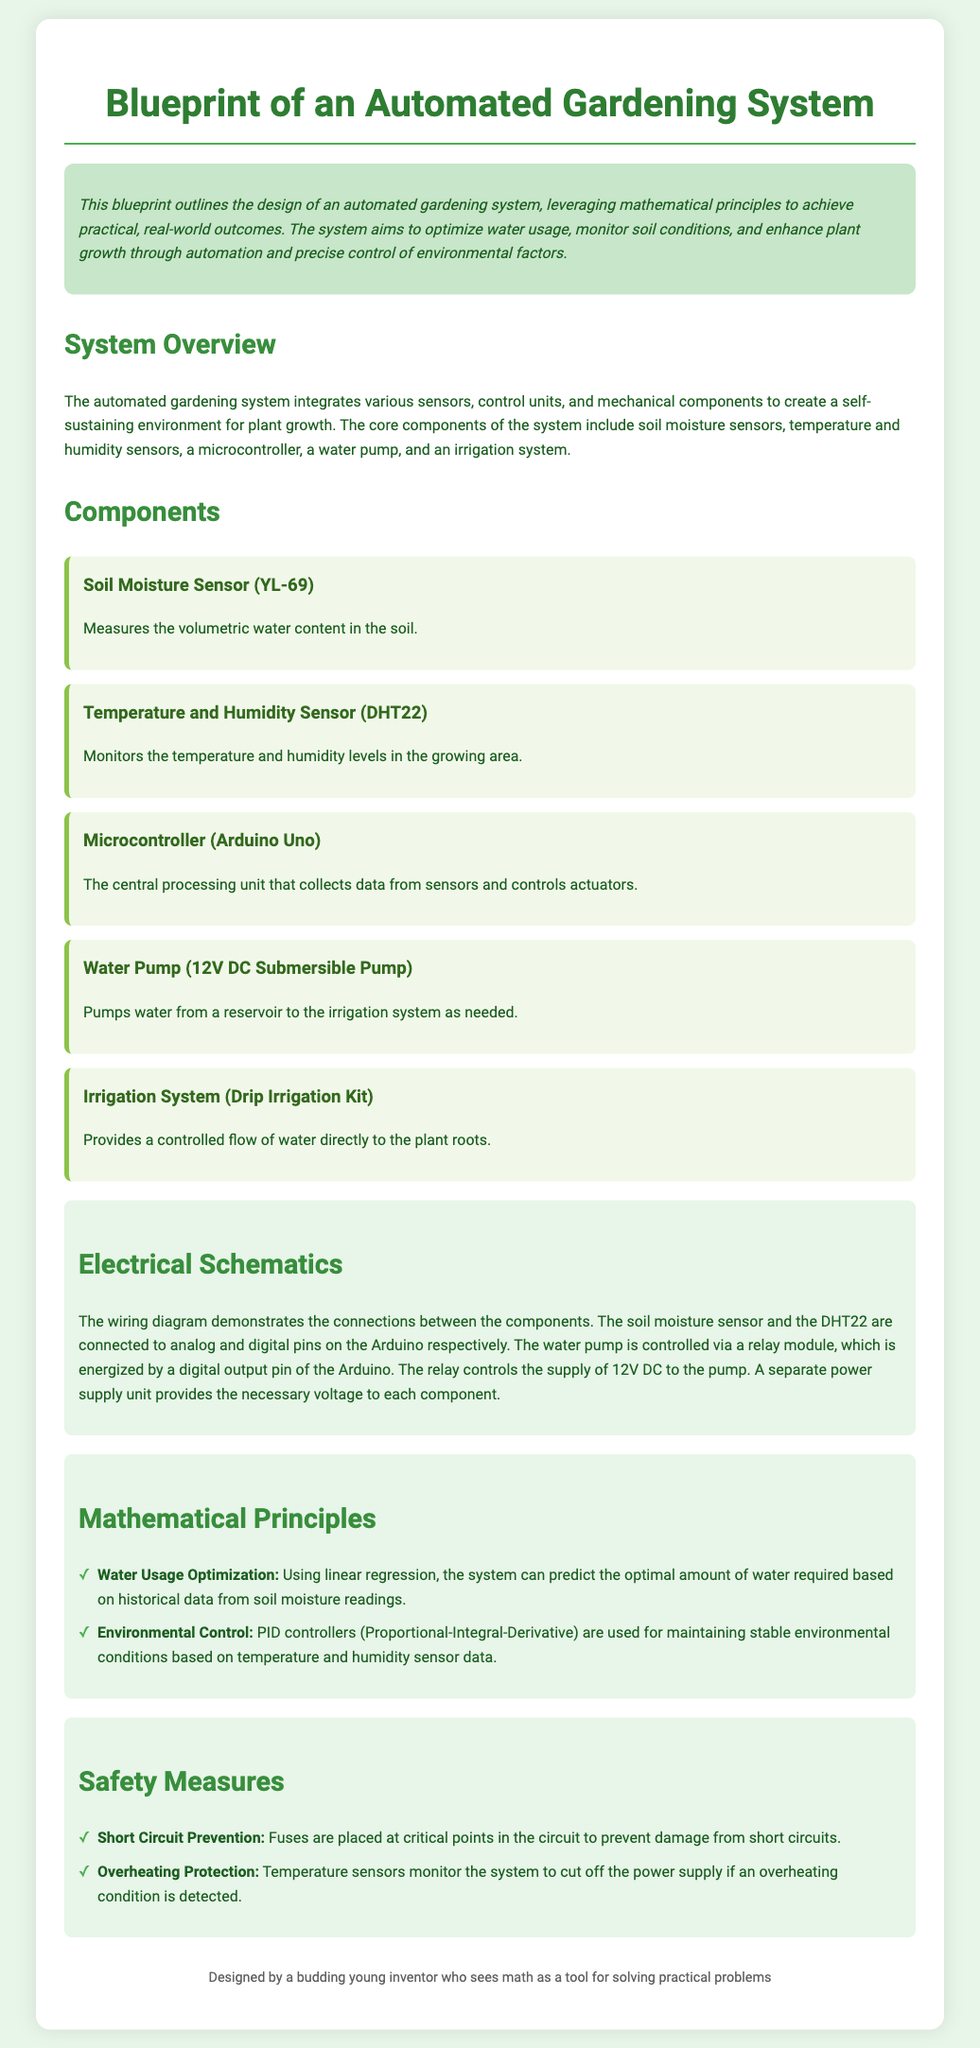What is the purpose of the automated gardening system? The purpose is to optimize water usage, monitor soil conditions, and enhance plant growth through automation and precise control of environmental factors.
Answer: Optimize water usage, monitor soil conditions, enhance plant growth What component measures soil moisture? This information is found under the components section, specifically detailing the type of sensor used for measuring soil moisture.
Answer: Soil Moisture Sensor (YL-69) Which microcontroller is mentioned in the document? The document states the specific microcontroller used in the system, which acts as the central processing unit.
Answer: Arduino Uno What type of irrigation system is used in the design? The document specifies the type of irrigation system integrated into the automated gardening setup.
Answer: Drip Irrigation Kit How is the water pump controlled? This question addresses how the pump is activated within the system based on the wiring and control setup described.
Answer: Via a relay module What mathematical principle is used for water usage optimization? The document mentions a specific analytical method used to optimize water usage based on sensor data.
Answer: Linear regression What safety measure is implemented to prevent short circuits? This question seeks information on the proactive measures outlined regarding electrical safety within the system.
Answer: Fuses What does PID stand for in the context of environmental control? The document refers to this control method but uses an abbreviation that requires elaboration.
Answer: Proportional-Integral-Derivative How many core components are listed in the overview section? This question considers the total number of components previously summarized in the document, reflecting the primary setup of the system.
Answer: Five 